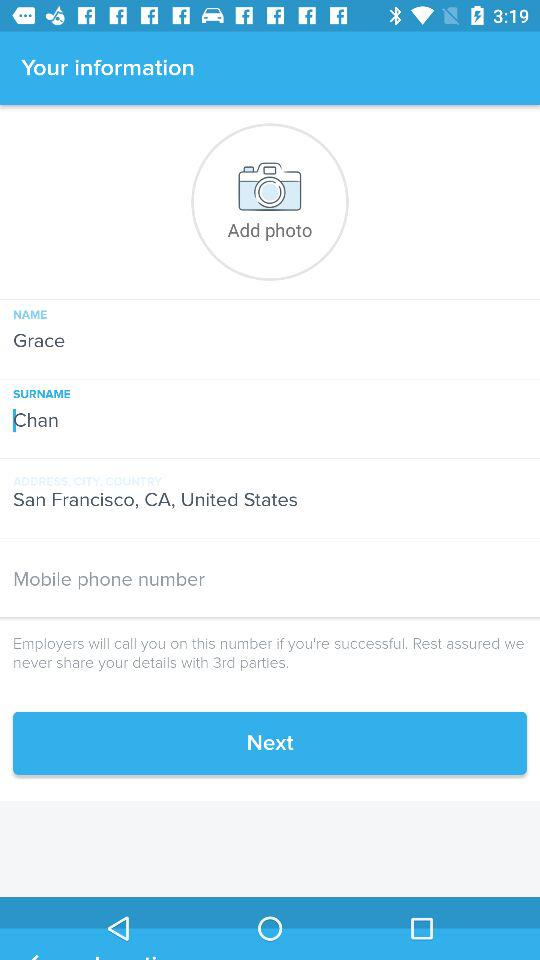What is the surname? The surname is Chan. 